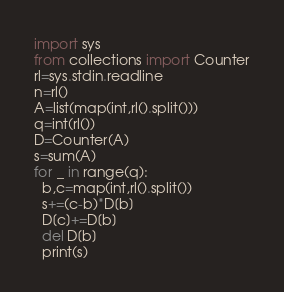<code> <loc_0><loc_0><loc_500><loc_500><_Python_>import sys
from collections import Counter
rl=sys.stdin.readline
n=rl()
A=list(map(int,rl().split()))
q=int(rl())
D=Counter(A)
s=sum(A)
for _ in range(q):
  b,c=map(int,rl().split())
  s+=(c-b)*D[b]
  D[c]+=D[b]
  del D[b]
  print(s)</code> 